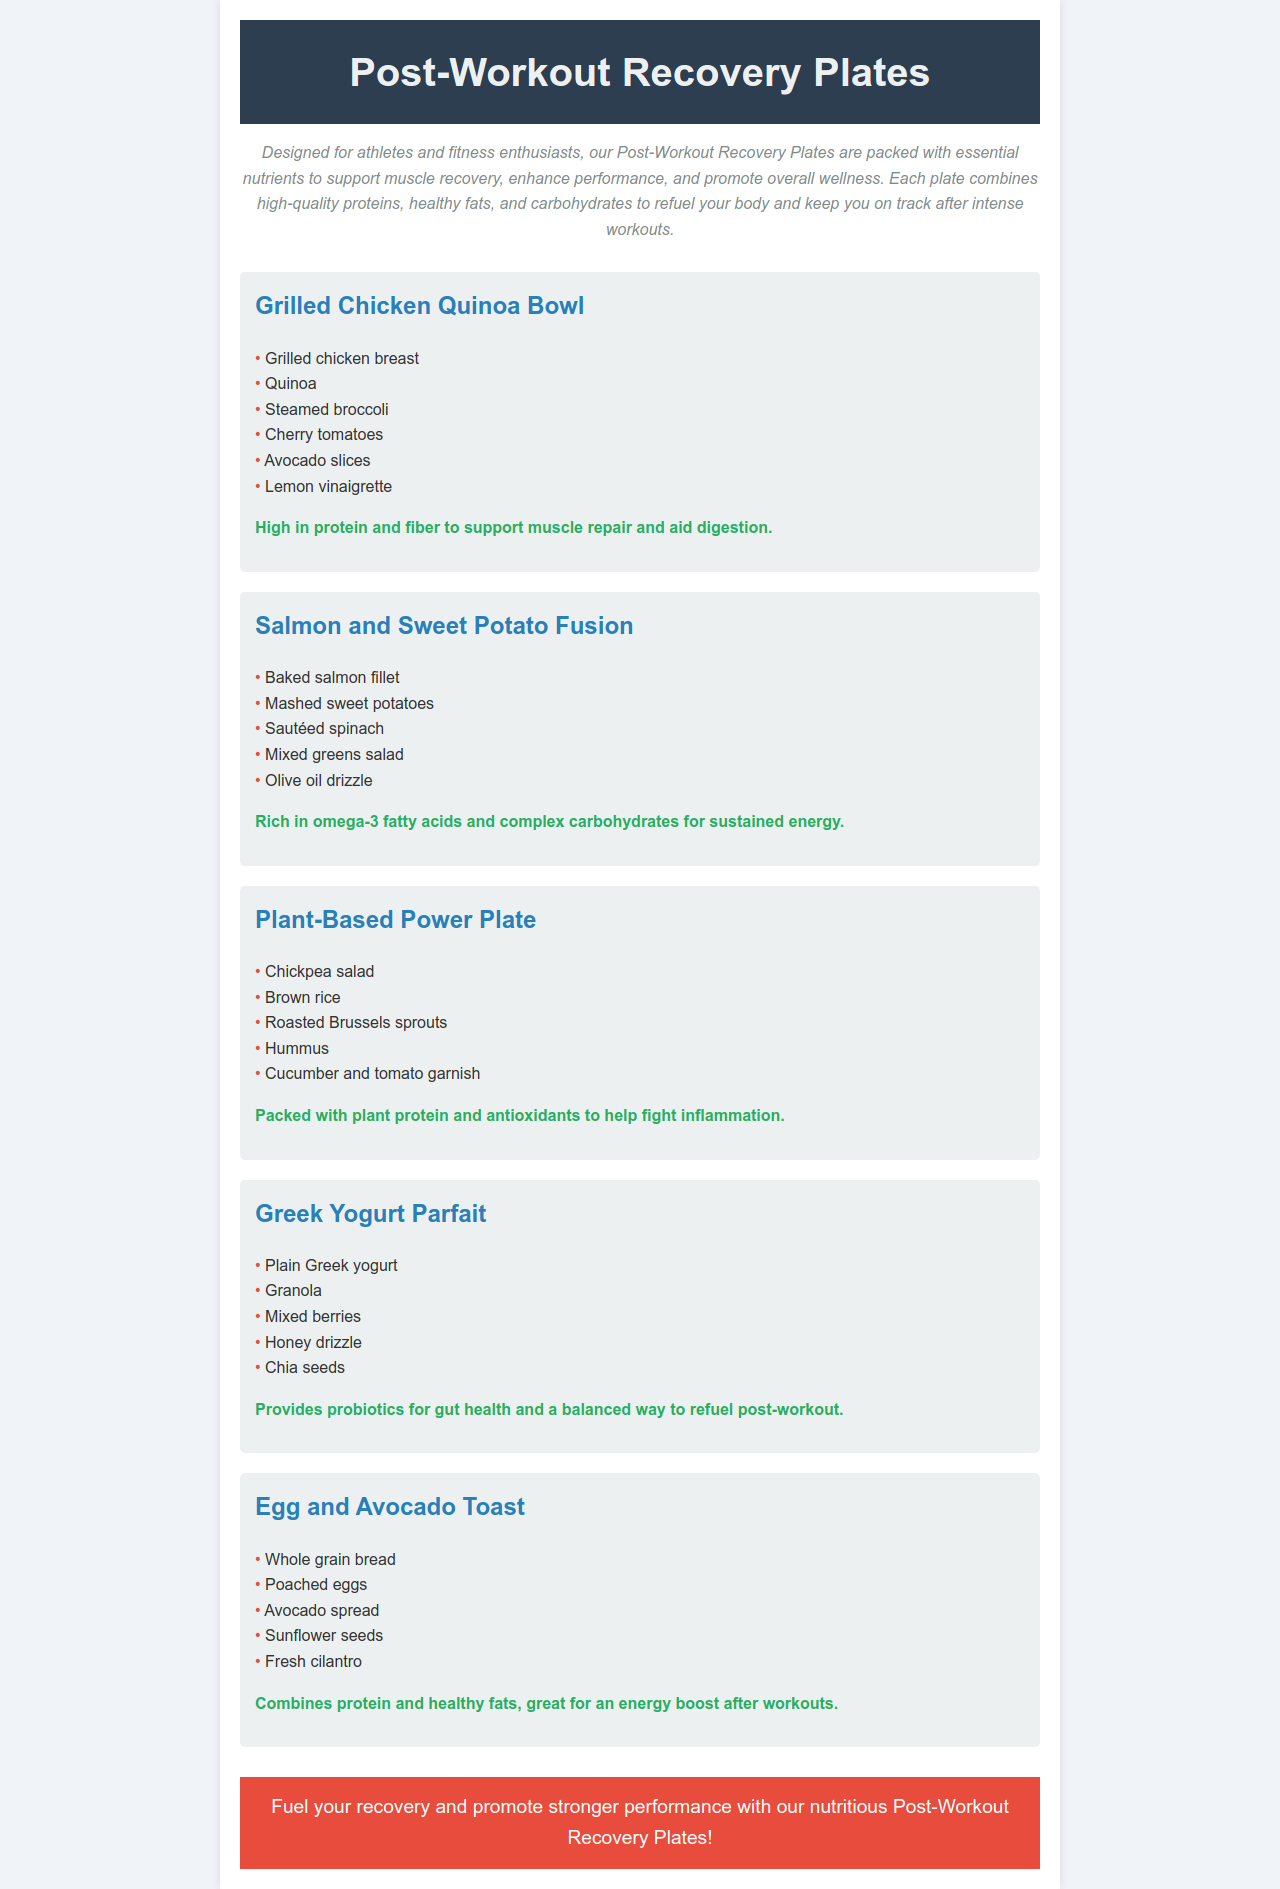What is the first dish listed on the menu? The first dish mentioned on the menu is "Grilled Chicken Quinoa Bowl."
Answer: Grilled Chicken Quinoa Bowl How many ingredients are listed for the Plant-Based Power Plate? The Plant-Based Power Plate has five ingredients listed.
Answer: 5 Which dish contains salmon? The dish that includes salmon is "Salmon and Sweet Potato Fusion."
Answer: Salmon and Sweet Potato Fusion What is the main protein source in the Egg and Avocado Toast? The main protein source in the Egg and Avocado Toast is poached eggs.
Answer: poached eggs What is the purpose of these Post-Workout Recovery Plates? The purpose is to support muscle recovery, enhance performance, and promote overall wellness.
Answer: support muscle recovery, enhance performance, and promote overall wellness Which dish is rich in omega-3 fatty acids? The dish rich in omega-3 fatty acids is "Salmon and Sweet Potato Fusion."
Answer: Salmon and Sweet Potato Fusion How does the Greek Yogurt Parfait benefit gut health? It provides probiotics which are beneficial for gut health.
Answer: probiotics What type of cuisine does the Plant-Based Power Plate focus on? The Plant-Based Power Plate focuses on plant-based ingredients.
Answer: plant-based 